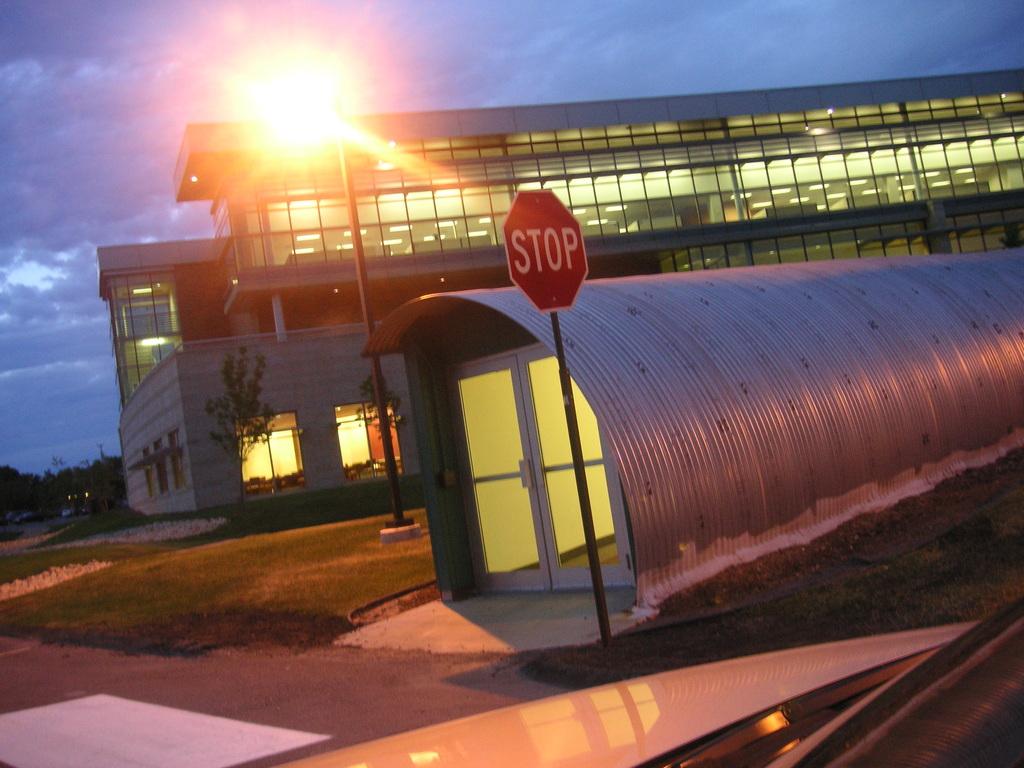What does the sign say?
Your response must be concise. Stop. 